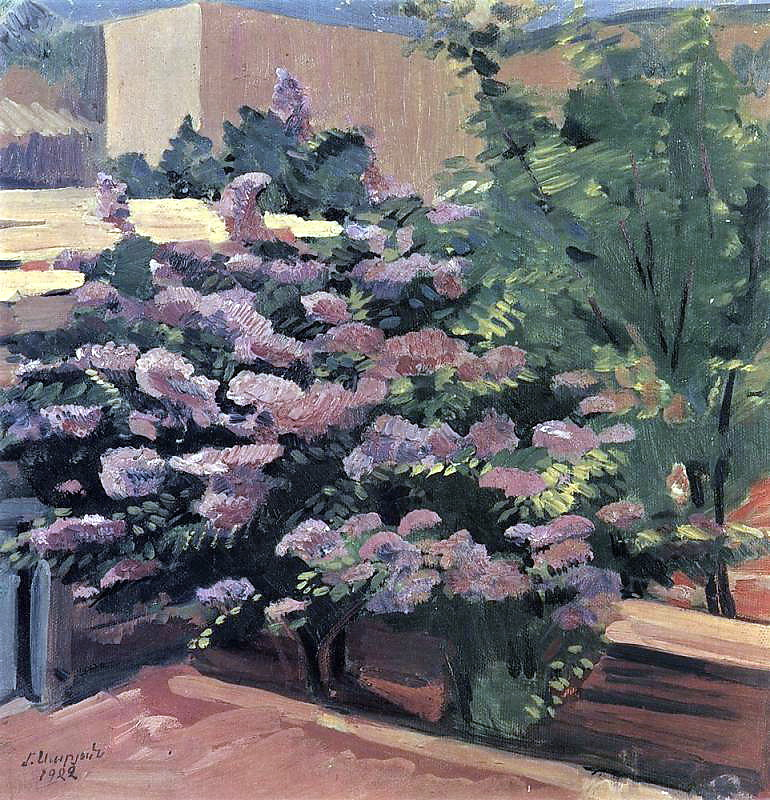Write a detailed description of the given image. The image presents a striking impressionist painting that immerses us in a peaceful garden scene. The focal point is a prominent bush filled with a profusion of pink and purple blossoms, occupying the majority of the canvas. Surrounding this central bush are various greenery and brownish tones suggesting the presence of other plants and possibly trees, contributing to a lush, verdant backdrop. A bit of blue sky is visible through the dense foliage, infusing the scene with a sense of openness and light. The painting features the signature 'L. Ury' and the year '1924' in the lower left corner, identifying the artist and date of creation. The use of rich, textured brushstrokes and a harmonious color palette are hallmarks of the impressionist style, which seeks to evoke the visual and emotional experience of a scene rather than its minute details. The artwork exquisitely captures the serene and natural beauty of a garden in full bloom, inviting viewers into an oasis of calm and floral splendor. 